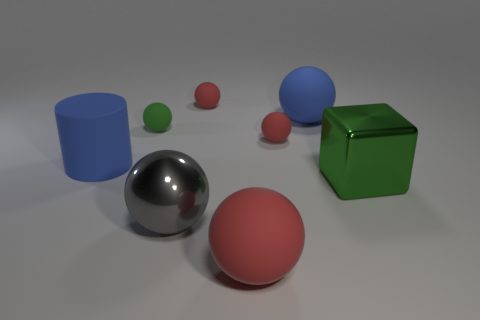Subtract all yellow cubes. How many red spheres are left? 3 Subtract all green balls. How many balls are left? 5 Subtract all large matte spheres. How many spheres are left? 4 Subtract all green spheres. Subtract all red cubes. How many spheres are left? 5 Add 1 gray things. How many objects exist? 9 Subtract all balls. How many objects are left? 2 Subtract all gray things. Subtract all blue matte spheres. How many objects are left? 6 Add 1 large cubes. How many large cubes are left? 2 Add 7 large blue spheres. How many large blue spheres exist? 8 Subtract 2 red balls. How many objects are left? 6 